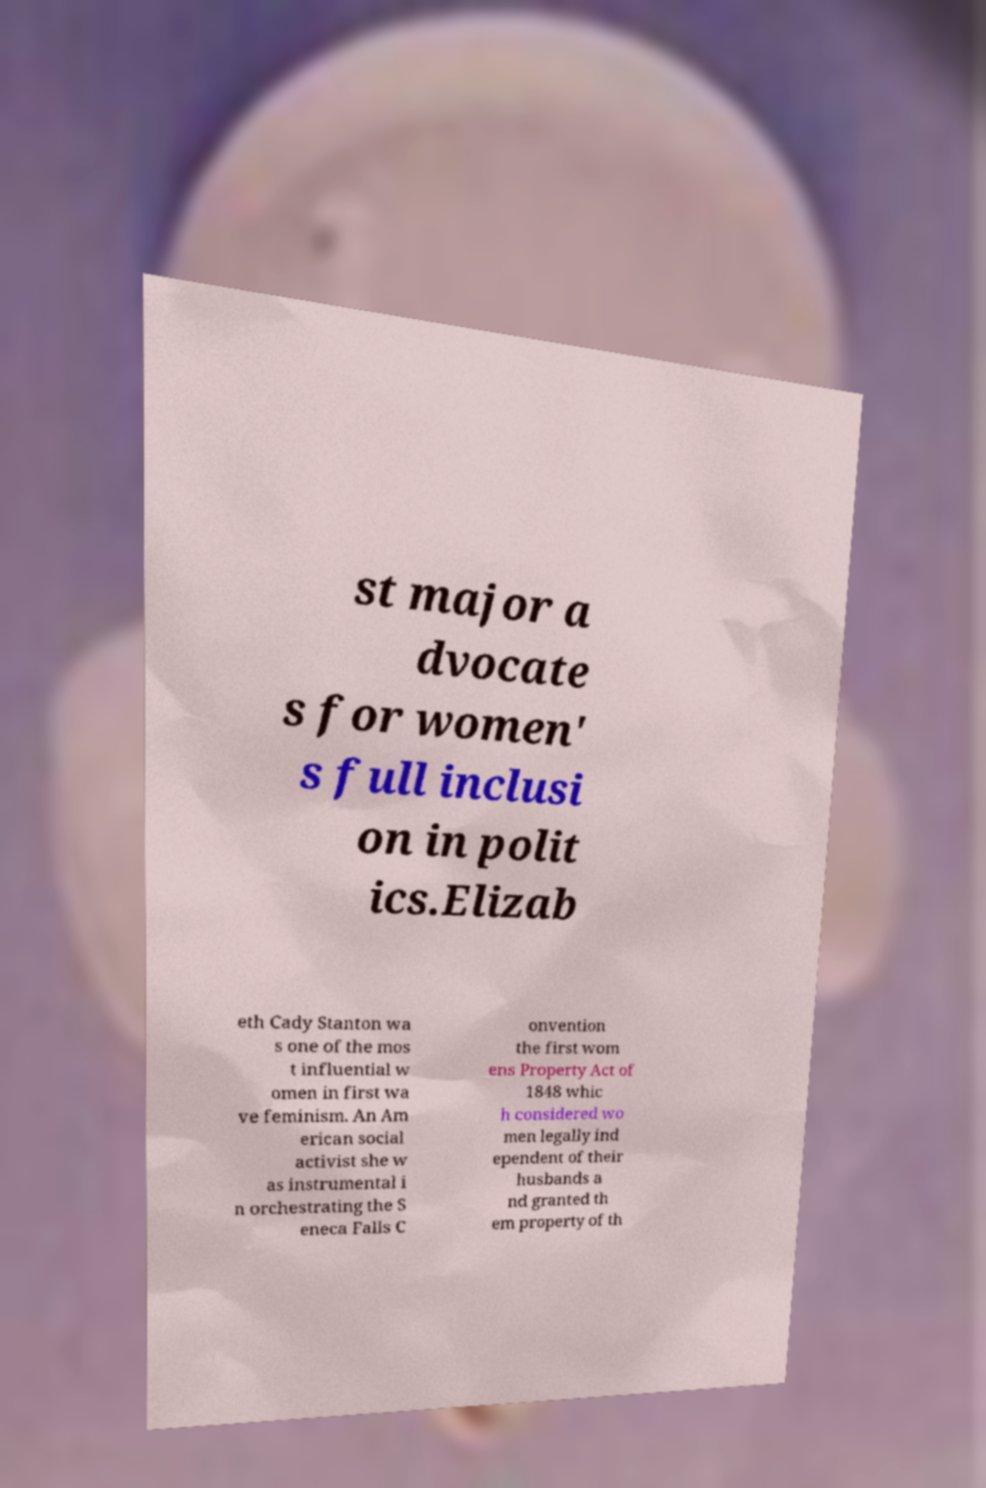Can you accurately transcribe the text from the provided image for me? st major a dvocate s for women' s full inclusi on in polit ics.Elizab eth Cady Stanton wa s one of the mos t influential w omen in first wa ve feminism. An Am erican social activist she w as instrumental i n orchestrating the S eneca Falls C onvention the first wom ens Property Act of 1848 whic h considered wo men legally ind ependent of their husbands a nd granted th em property of th 